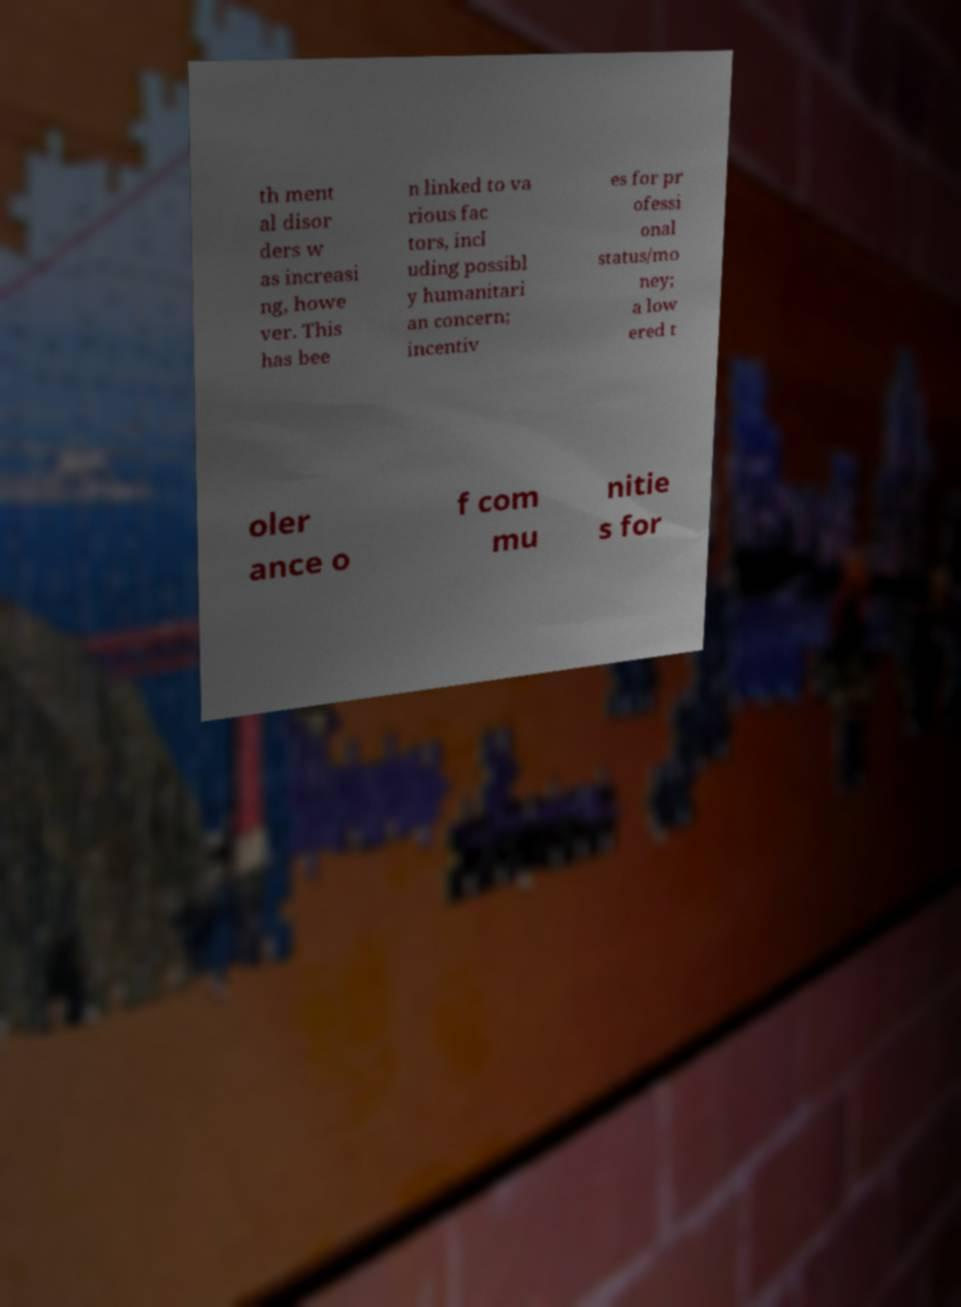For documentation purposes, I need the text within this image transcribed. Could you provide that? th ment al disor ders w as increasi ng, howe ver. This has bee n linked to va rious fac tors, incl uding possibl y humanitari an concern; incentiv es for pr ofessi onal status/mo ney; a low ered t oler ance o f com mu nitie s for 